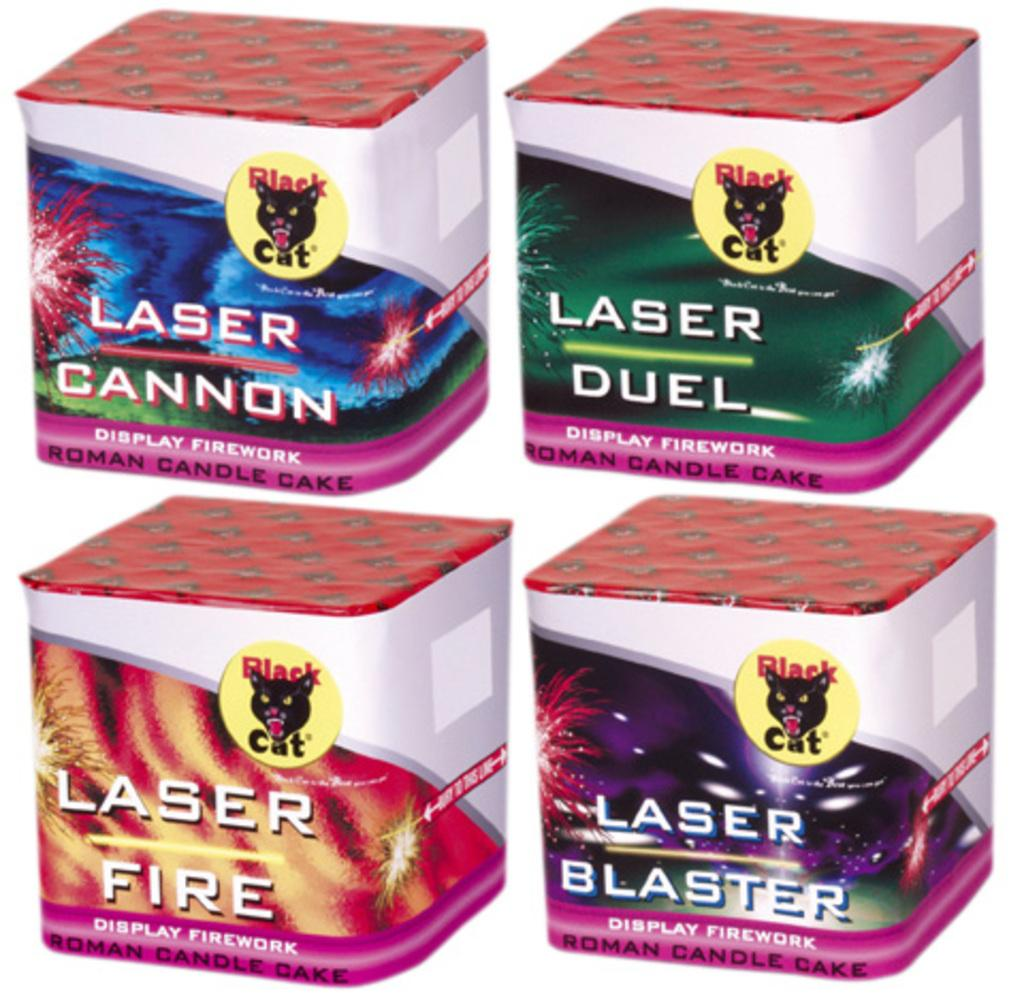<image>
Summarize the visual content of the image. Four boxes of fireworks all contain the word laser in their name. 